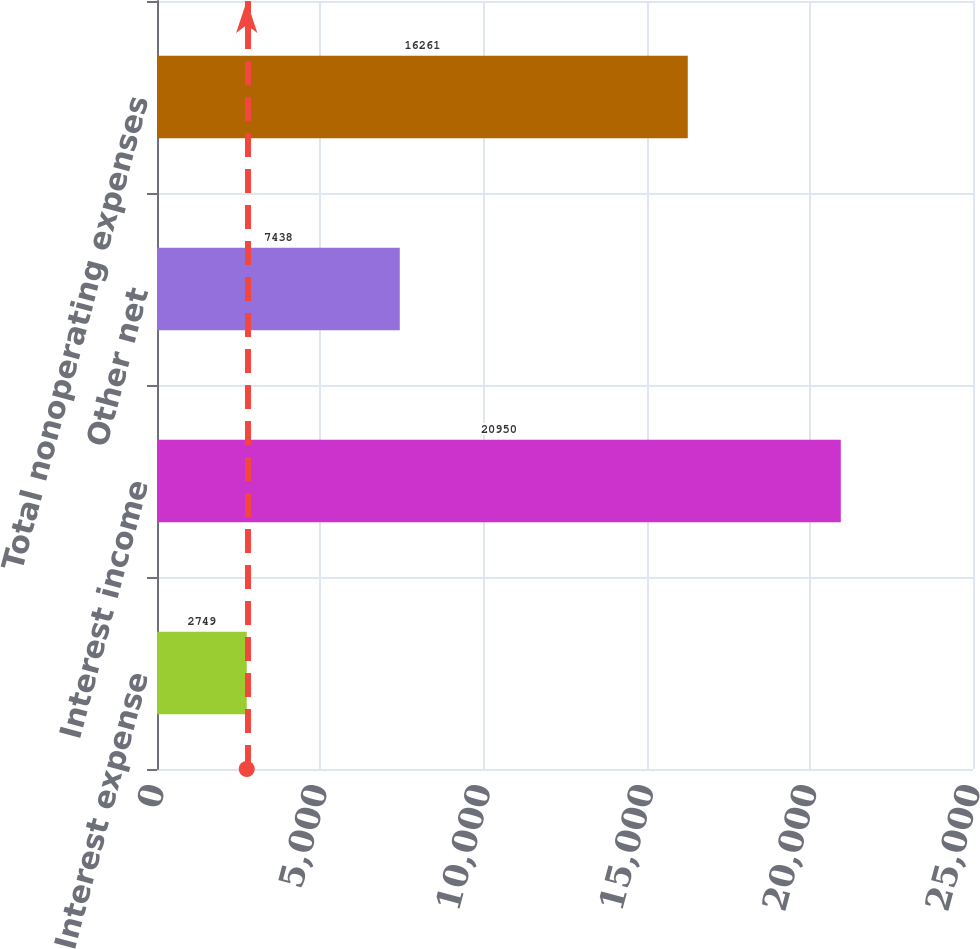<chart> <loc_0><loc_0><loc_500><loc_500><bar_chart><fcel>Interest expense<fcel>Interest income<fcel>Other net<fcel>Total nonoperating expenses<nl><fcel>2749<fcel>20950<fcel>7438<fcel>16261<nl></chart> 